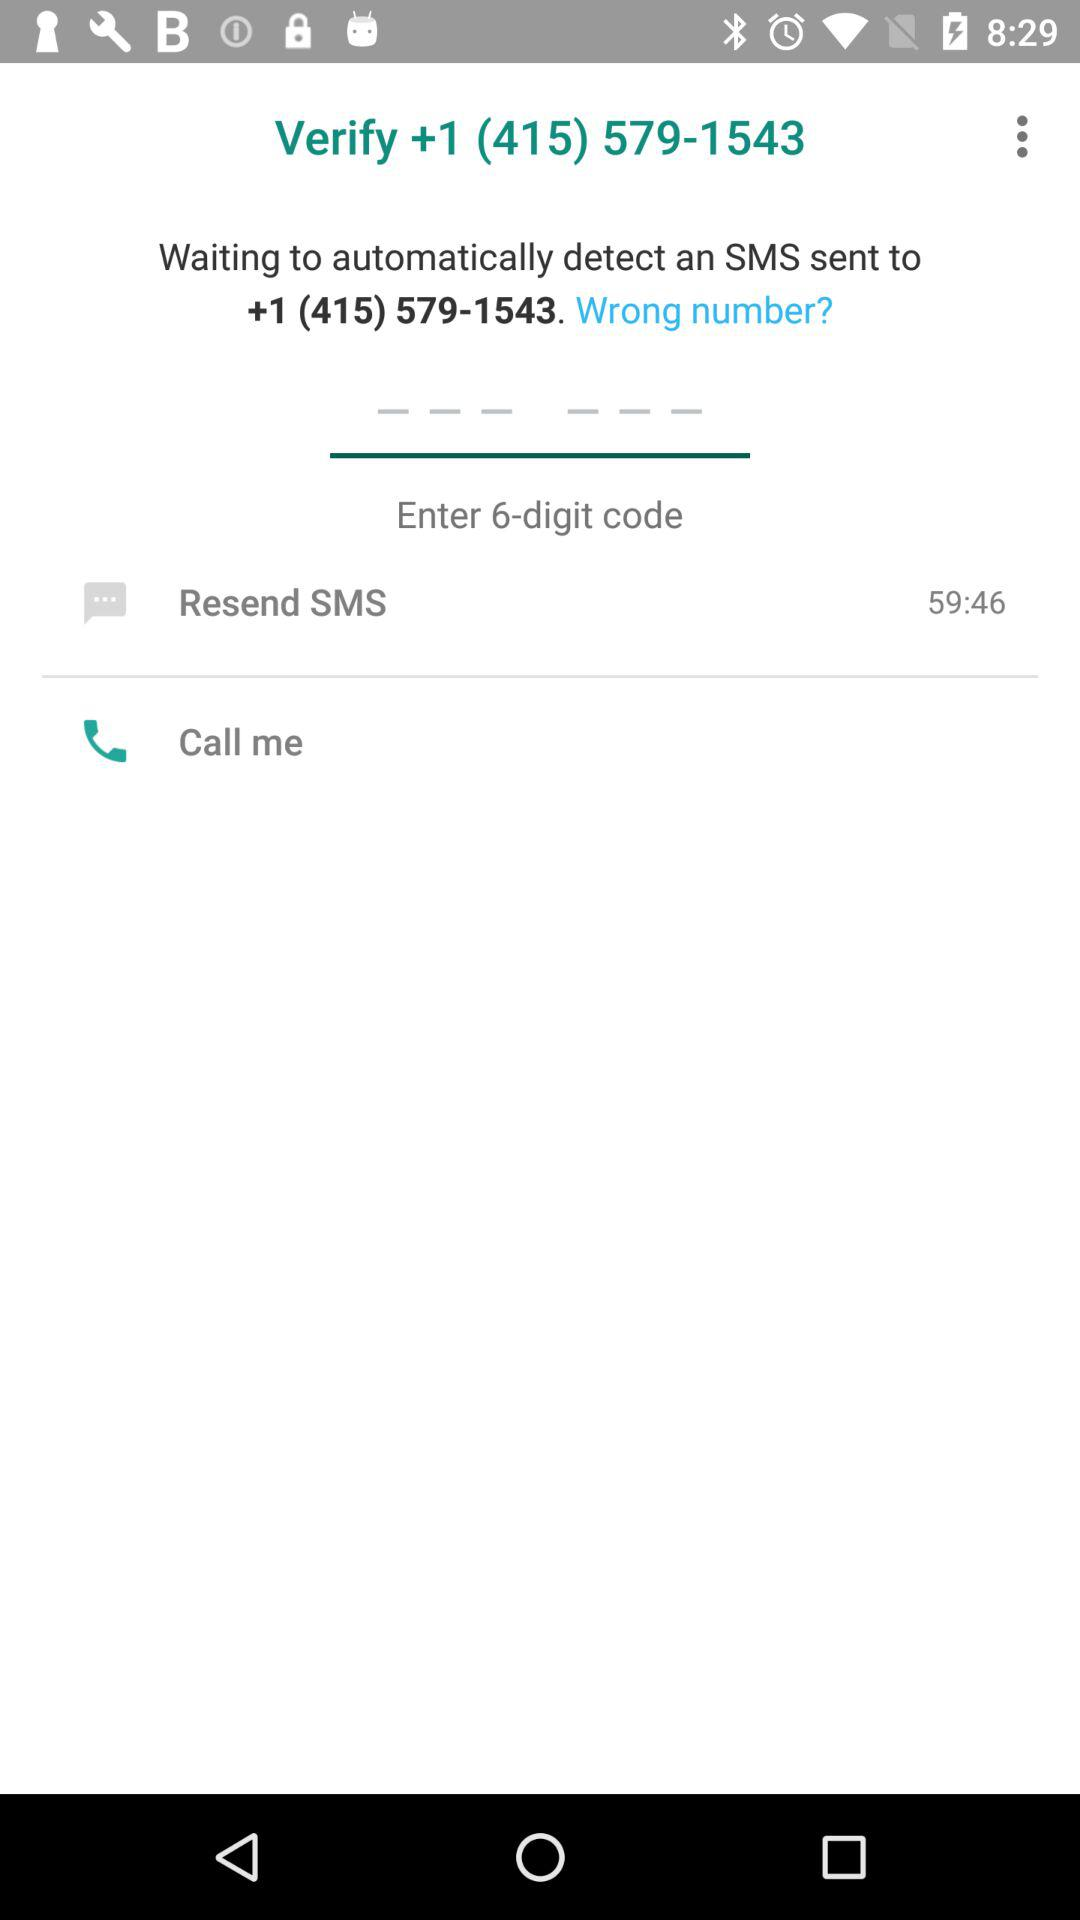How many options are there for recieving the code?
Answer the question using a single word or phrase. 2 